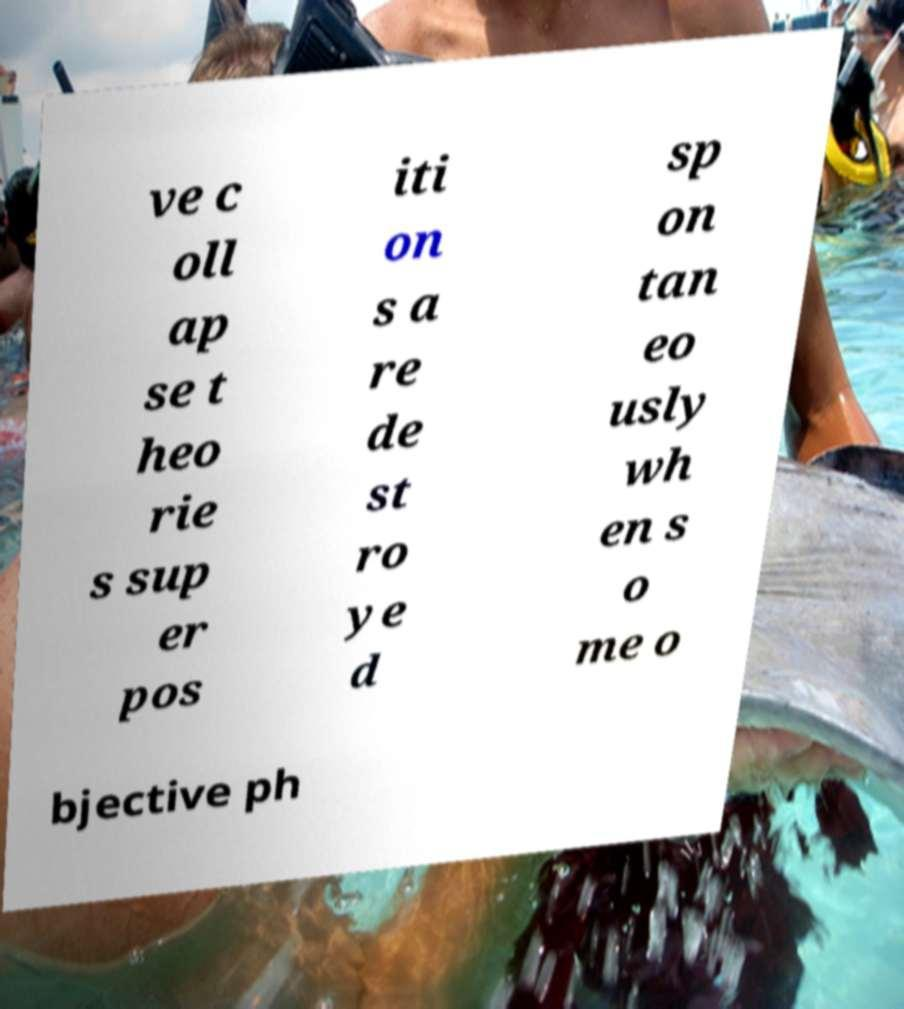What messages or text are displayed in this image? I need them in a readable, typed format. ve c oll ap se t heo rie s sup er pos iti on s a re de st ro ye d sp on tan eo usly wh en s o me o bjective ph 